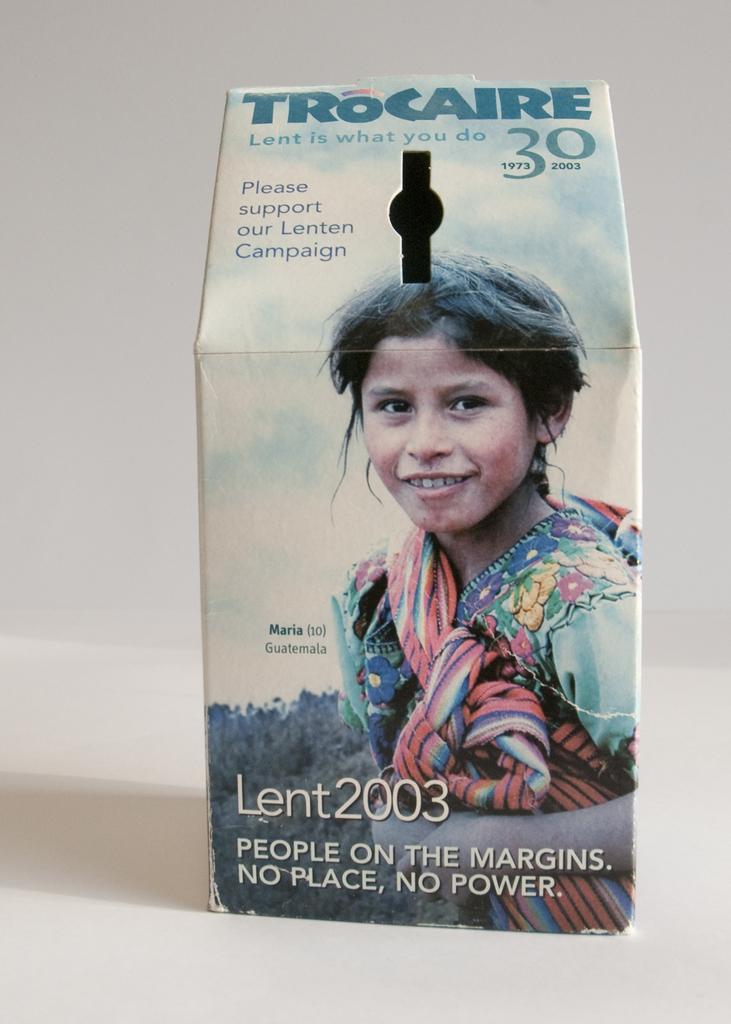In one or two sentences, can you explain what this image depicts? Here we can see a box on a platform and on the box we can see a girl picture and text written on it. 